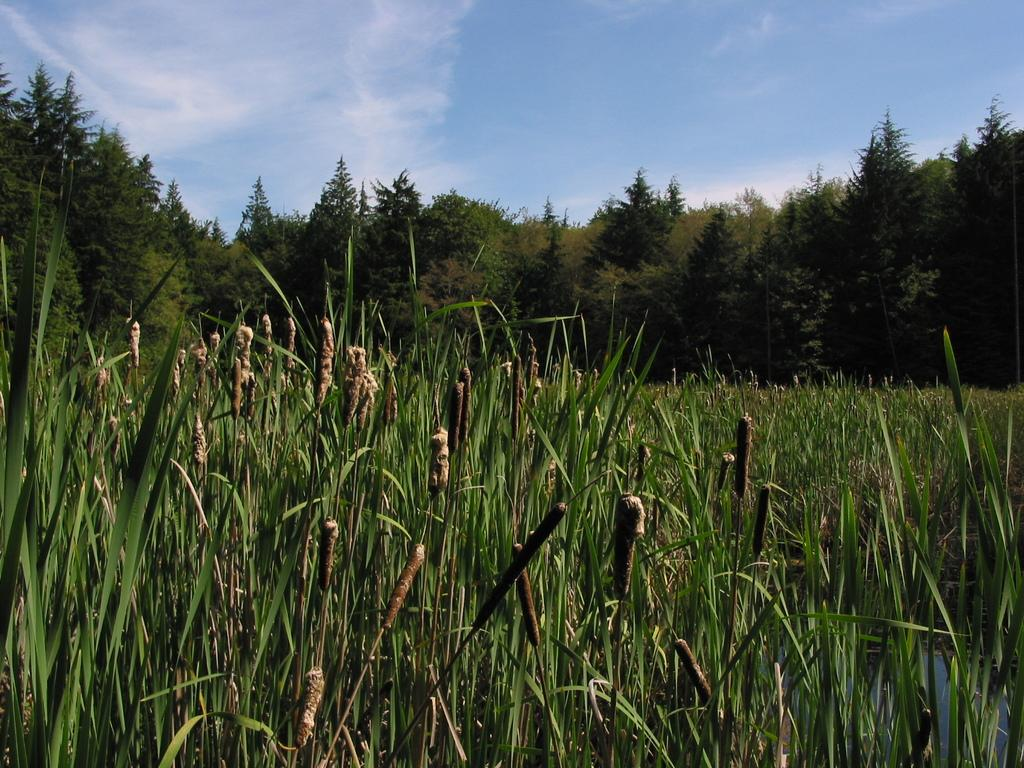What type of vegetation is in the foreground of the image? There is grass in the foreground of the image. What can be seen in the background of the image? There are trees and the sky visible in the background of the image. Can you describe the sky in the image? The sky is visible in the background of the image, and there is a cloud visible in the sky. What type of wrench is being used to calculate the distance between the trees in the image? There is no wrench or calculator present in the image. The image only features grass, trees, and a cloud in the sky. 